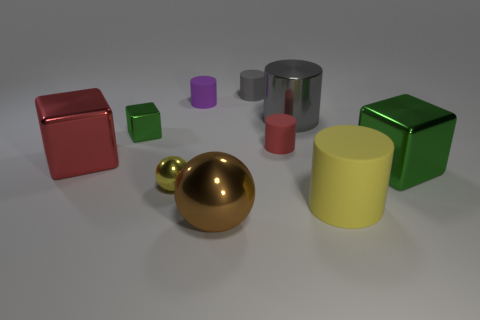Subtract all yellow cylinders. How many green cubes are left? 2 Subtract all purple cylinders. How many cylinders are left? 4 Subtract all shiny cylinders. How many cylinders are left? 4 Subtract 2 cylinders. How many cylinders are left? 3 Subtract all blue cylinders. Subtract all purple blocks. How many cylinders are left? 5 Subtract all balls. How many objects are left? 8 Add 9 tiny yellow metal things. How many tiny yellow metal things are left? 10 Add 6 large blue objects. How many large blue objects exist? 6 Subtract 0 green balls. How many objects are left? 10 Subtract all big red metallic things. Subtract all big objects. How many objects are left? 4 